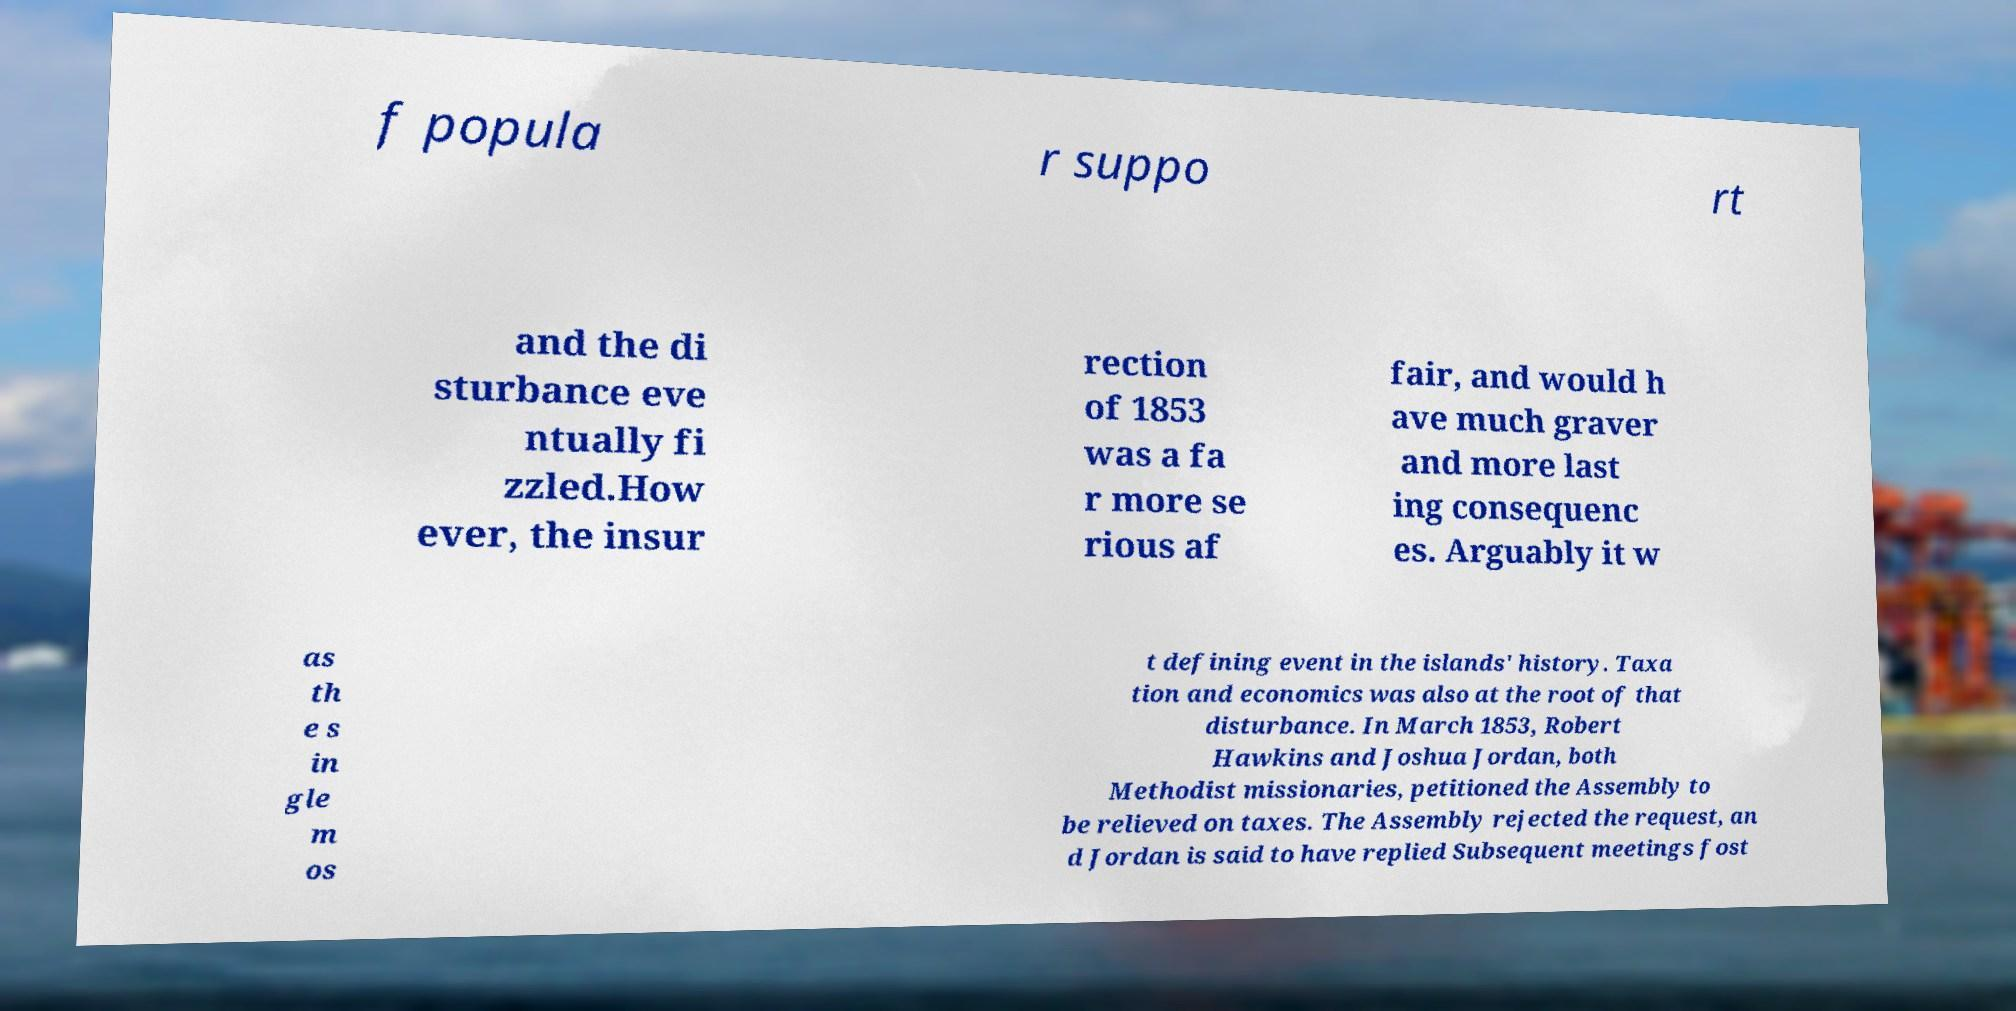Please identify and transcribe the text found in this image. f popula r suppo rt and the di sturbance eve ntually fi zzled.How ever, the insur rection of 1853 was a fa r more se rious af fair, and would h ave much graver and more last ing consequenc es. Arguably it w as th e s in gle m os t defining event in the islands' history. Taxa tion and economics was also at the root of that disturbance. In March 1853, Robert Hawkins and Joshua Jordan, both Methodist missionaries, petitioned the Assembly to be relieved on taxes. The Assembly rejected the request, an d Jordan is said to have replied Subsequent meetings fost 